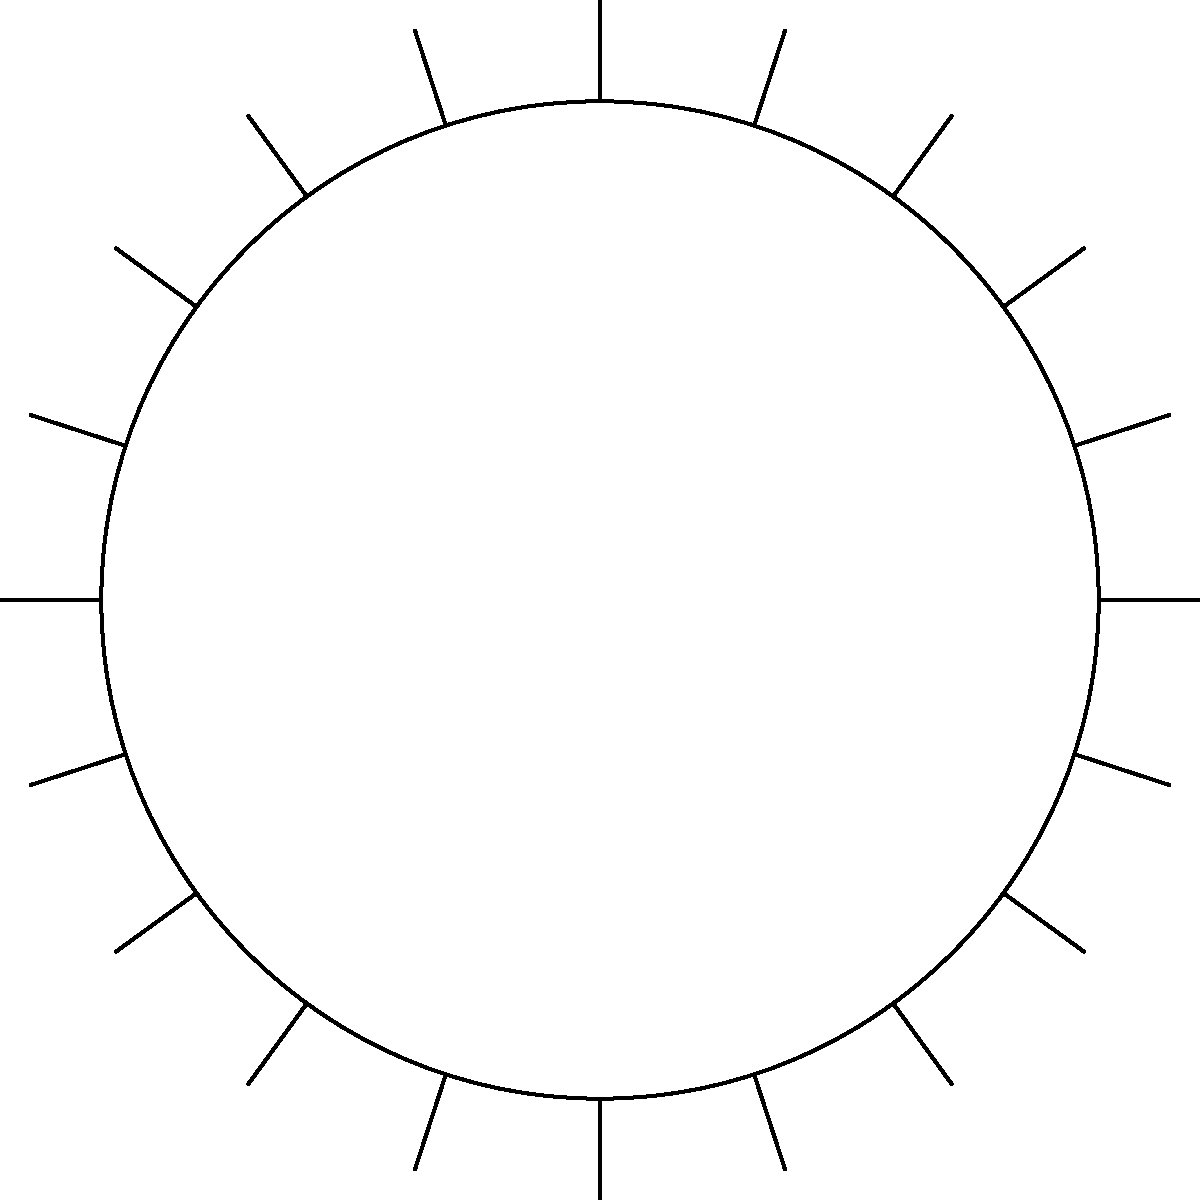In the world of mechanical engineering, gears play a crucial role in power transmission. Imagine you're designing a set for a play about industrial revolution, and you need to accurately represent different types of gears. Looking at the illustrations above, identify which gear (A, B, or C) represents a helical gear, and briefly explain its main advantage over the other types shown. To answer this question, let's analyze each gear illustration:

1. Gear A: This gear has straight teeth that are parallel to the axis of rotation. This is characteristic of a spur gear.

2. Gear B: The teeth of this gear are set at an angle to the axis of rotation, creating a spiral pattern. This is the defining feature of a helical gear.

3. Gear C: This gear has teeth cut at an angle, forming a conical shape. This is typical of a bevel gear.

The helical gear (B) has several advantages over the other types shown:

1. Smoother operation: The angled teeth engage gradually, reducing noise and vibration compared to spur gears.
2. Higher load capacity: The larger contact area between teeth allows for greater force transmission.
3. Ability to mesh non-parallel shafts: Helical gears can be used to connect shafts that are not parallel to each other.

In the context of a play about the industrial revolution, helical gears would represent a significant technological advancement, showcasing the evolution of machinery towards more efficient and quieter operation.
Answer: B (Helical gear); advantage: smoother, quieter operation 